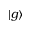Convert formula to latex. <formula><loc_0><loc_0><loc_500><loc_500>| g \rangle</formula> 